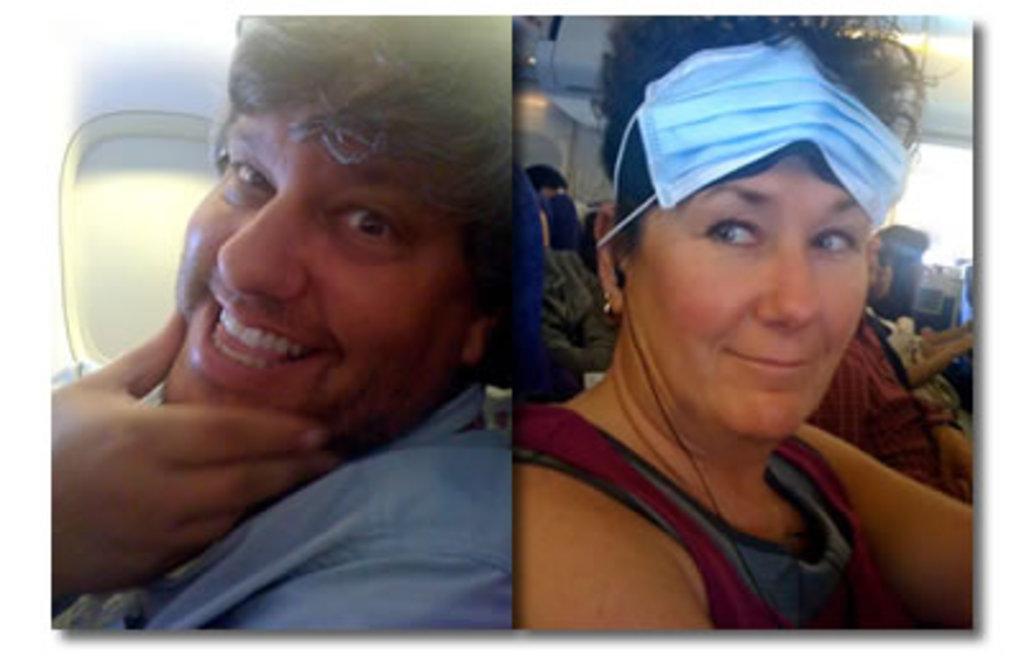How would you summarize this image in a sentence or two? It is a collage image. In this image there are people sitting on the aeroplane. On both right and left side of the image there are windows. 